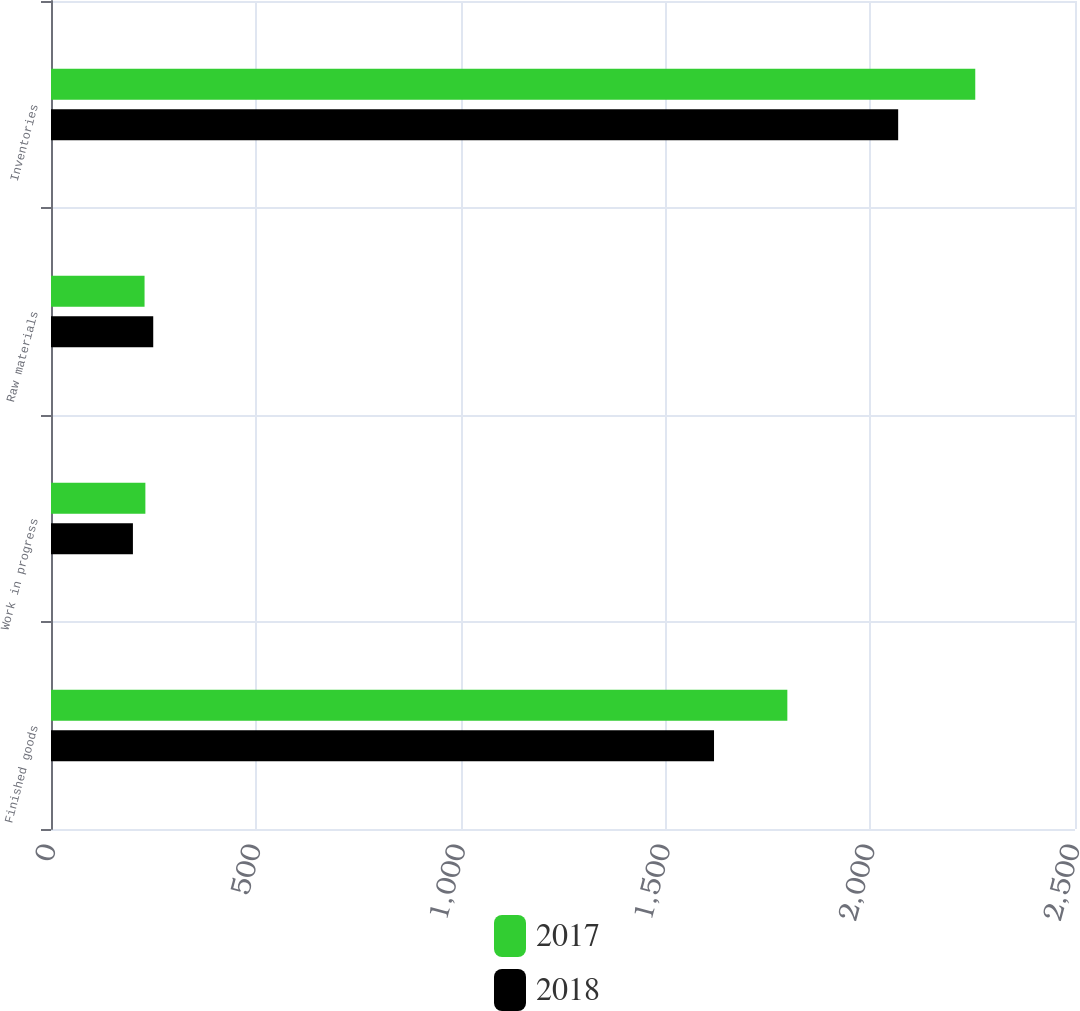Convert chart. <chart><loc_0><loc_0><loc_500><loc_500><stacked_bar_chart><ecel><fcel>Finished goods<fcel>Work in progress<fcel>Raw materials<fcel>Inventories<nl><fcel>2017<fcel>1797.7<fcel>230.4<fcel>228.4<fcel>2256.5<nl><fcel>2018<fcel>1618.7<fcel>200<fcel>249.6<fcel>2068.3<nl></chart> 